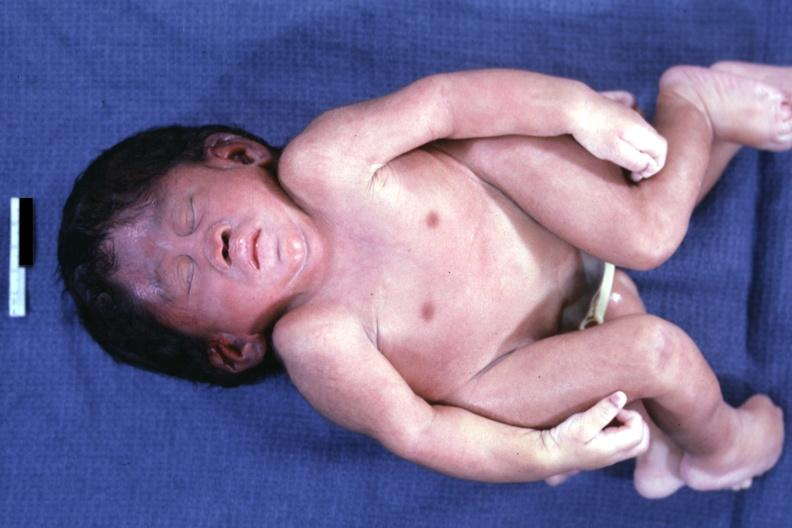does this image show anterior view?
Answer the question using a single word or phrase. Yes 